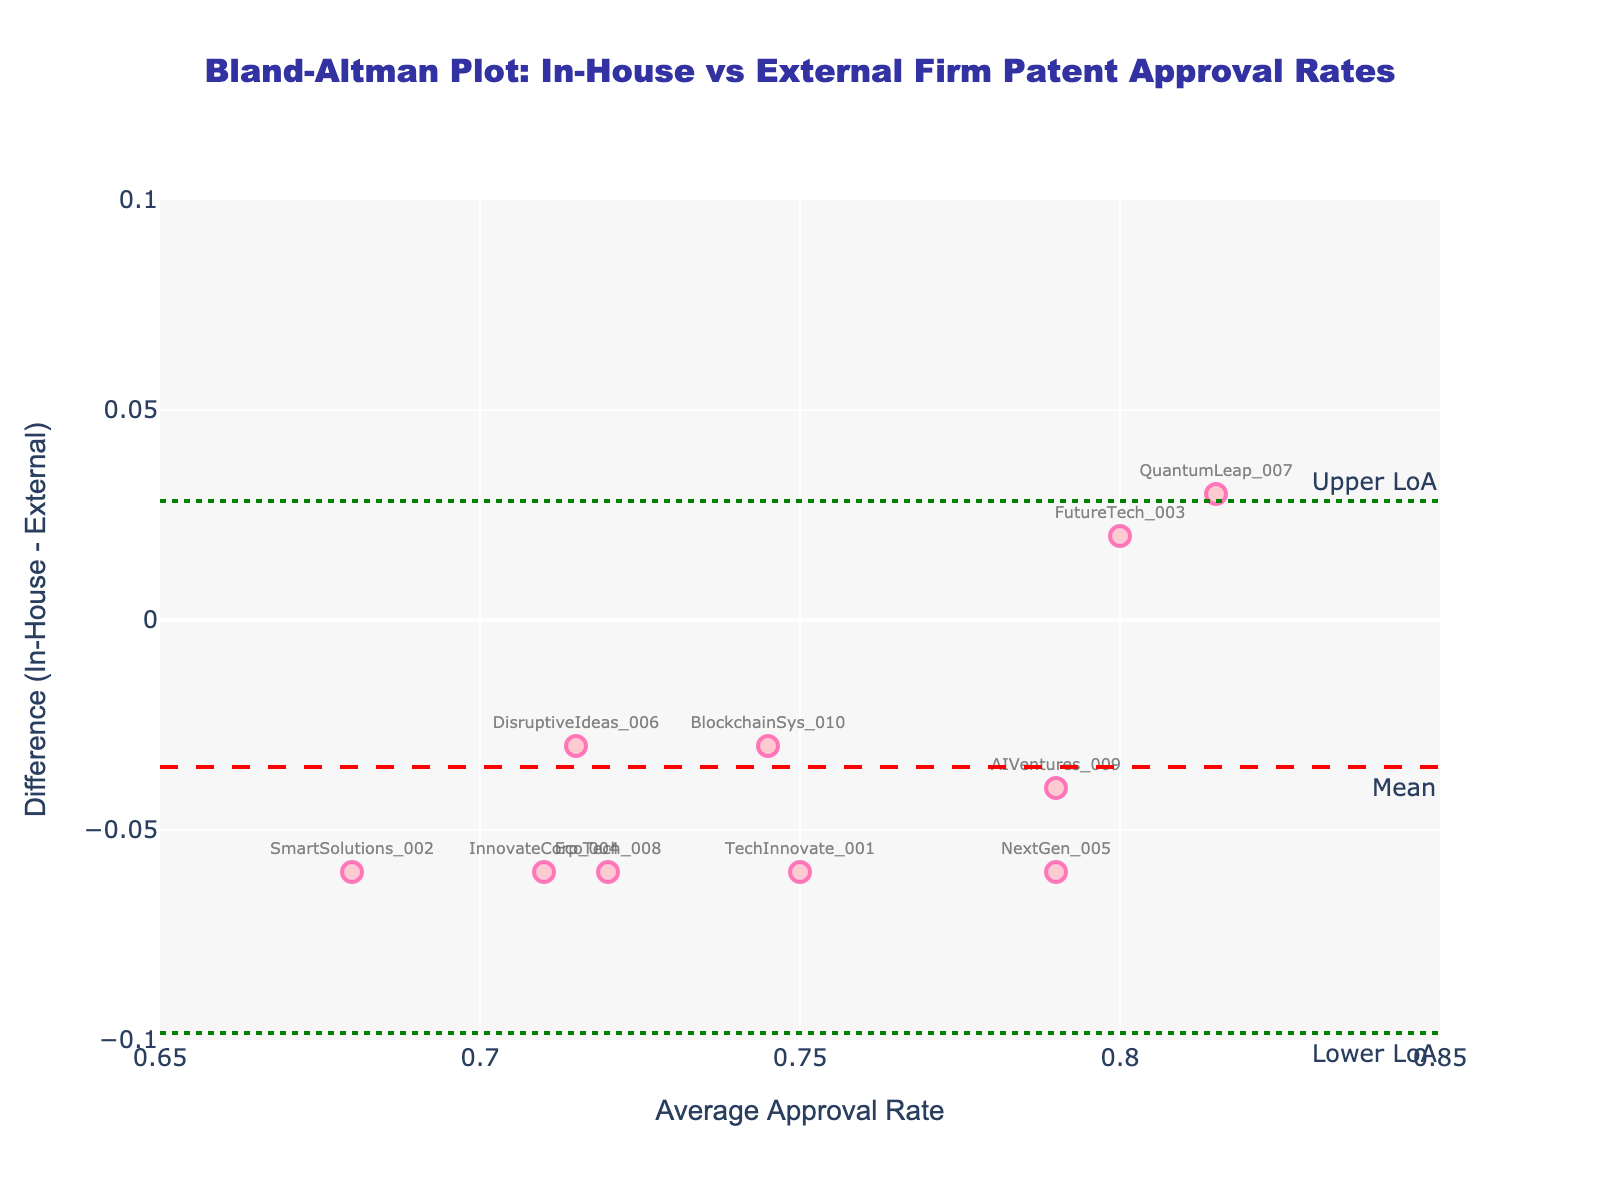What's the title of the figure? The title of the figure is prominently displayed at the top, indicating the overall content and context of the visual representation. It helps identify what comparison is being made.
Answer: Bland-Altman Plot: In-House vs External Firm Patent Approval Rates How many data points are plotted in the figure? By counting the number of markers or data labels in the scatter plot, we can determine the number of data points. Each data point represents a unique patent ID.
Answer: 10 Which data point has the highest average approval rate? By looking at the x-axis values and identifying the highest one, we can determine which data point has the highest average approval rate. Here, it corresponds to the 'x' value.
Answer: QuantumLeap_007 What are the values of the upper and lower limits of agreement? The Bland-Altman plot has dashed horizontal lines marking the upper and lower limits of agreement. These values are typically annotated on the plot.
Answer: Upper: 0.0838, Lower: -0.0838 What's the mean difference between In-House and External Firm approval rates? The mean difference is marked by a dashed horizontal line across the plot, labeled "Mean". This visually represents the average difference between the approval rates of the two groups.
Answer: -0.008 Is there a systematic bias between In-House and External Firm approval rates based on the plot? Systematic bias can be inferred if the mean difference is not centered around zero. We examine the mean difference line to make this determination based on visual inspection.
Answer: No significant bias Which data points have a negative difference (In-House - External)? To find the data points with negative differences, look for markers below the mean difference line (-0.008). These represent where the In-House approval rate is lower than the External Firm's.
Answer: TechInnovate_001, SmartSolutions_002, InnovateCorp_004, EcoTech_008, BlockchainSys_010 Which data point exhibits the largest difference (absolute value) between In-House and External Firm approval rates? Identify the marker that is furthest from the mean difference line, both above and below. The largest vertical distance from the mean difference line corresponds to the largest difference.
Answer: NextGen_005 What's the average approval rate for TechInnovate_001 and SmartSolutions_002? To find the average of these two data points' average approval rates, add the two average approval rates and divide by 2.
Answer: (0.75 + 0.68) / 2 = 0.715 Is there a trend visible in the differences relative to the average approval rates? Look for any pattern in the scatter plot of differences vs. average approval rates. If data points tend to cluster in a particular direction, a trend may be apparent.
Answer: No clear trend visible 